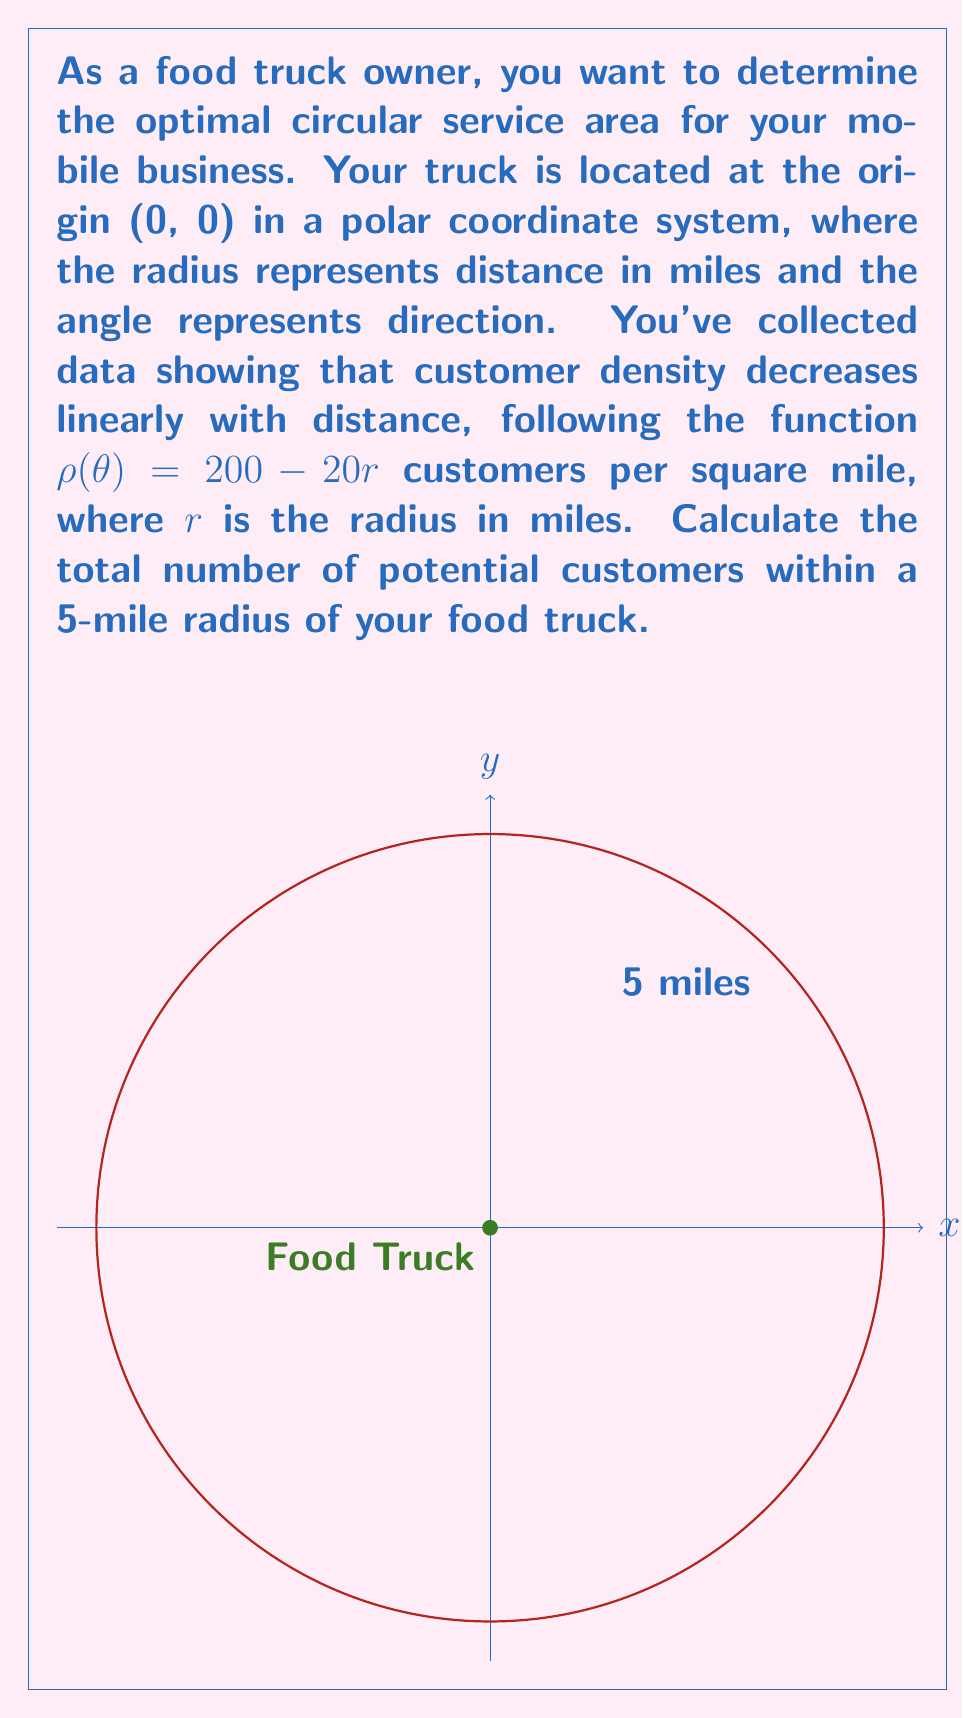Teach me how to tackle this problem. To solve this problem, we need to use the formula for the number of customers in a polar region:

$$N = \int_0^{2\pi} \int_0^R \rho(r) r \, dr \, d\theta$$

Where:
- $N$ is the total number of customers
- $R$ is the radius of the service area (5 miles in this case)
- $\rho(r) = 200 - 20r$ is the customer density function

Step 1: Set up the double integral
$$N = \int_0^{2\pi} \int_0^5 (200 - 20r) r \, dr \, d\theta$$

Step 2: Solve the inner integral with respect to $r$
$$\int_0^5 (200r - 20r^2) \, dr = \left[100r^2 - \frac{20}{3}r^3\right]_0^5$$
$$= \left(100 \cdot 25 - \frac{20}{3} \cdot 125\right) - (0) = 2500 - \frac{2500}{3} = \frac{5000}{3}$$

Step 3: Multiply by $2\pi$ to account for the outer integral
$$N = 2\pi \cdot \frac{5000}{3} = \frac{10000\pi}{3}$$

Step 4: Calculate the final result
$$N = \frac{10000\pi}{3} \approx 10,471.98$$
Answer: $\frac{10000\pi}{3}$ customers (approximately 10,472) 